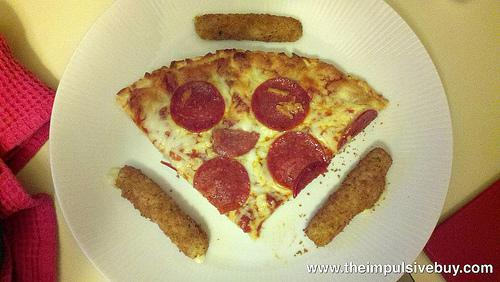Question: what is white?
Choices:
A. Snow.
B. Plate.
C. Yogurt.
D. Butter.
Answer with the letter. Answer: B Question: why is there a website on the picture?
Choices:
A. Advertisment.
B. Information.
C. Warning.
D. Directions.
Answer with the letter. Answer: A Question: what is around the pizza?
Choices:
A. Breadsticks.
B. Cheese sticks.
C. Salad.
D. Pasta.
Answer with the letter. Answer: B Question: what is red?
Choices:
A. Napkin.
B. Placemat.
C. Fork.
D. Spoon.
Answer with the letter. Answer: A 